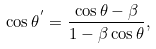Convert formula to latex. <formula><loc_0><loc_0><loc_500><loc_500>\cos \theta ^ { ^ { \prime } } = \frac { \cos \theta - \beta } { 1 - \beta \cos \theta } ,</formula> 